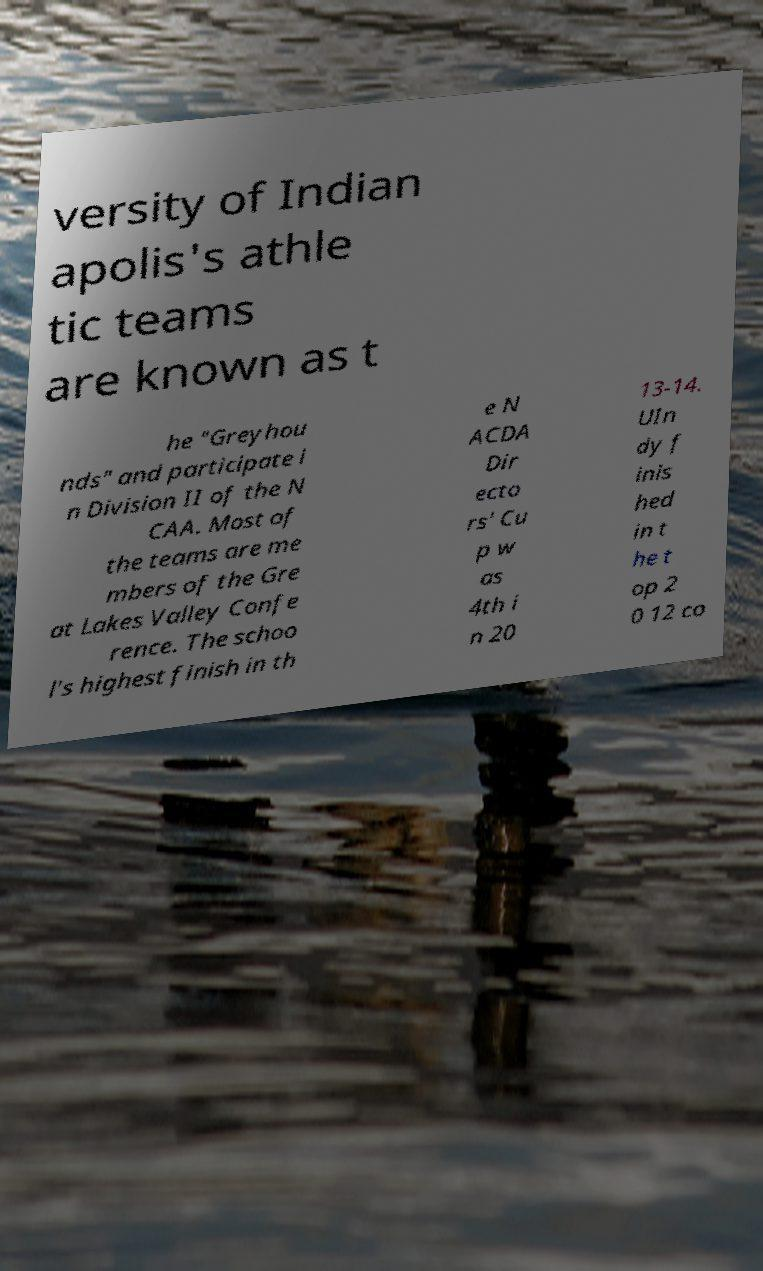Can you accurately transcribe the text from the provided image for me? versity of Indian apolis's athle tic teams are known as t he "Greyhou nds" and participate i n Division II of the N CAA. Most of the teams are me mbers of the Gre at Lakes Valley Confe rence. The schoo l's highest finish in th e N ACDA Dir ecto rs' Cu p w as 4th i n 20 13-14. UIn dy f inis hed in t he t op 2 0 12 co 